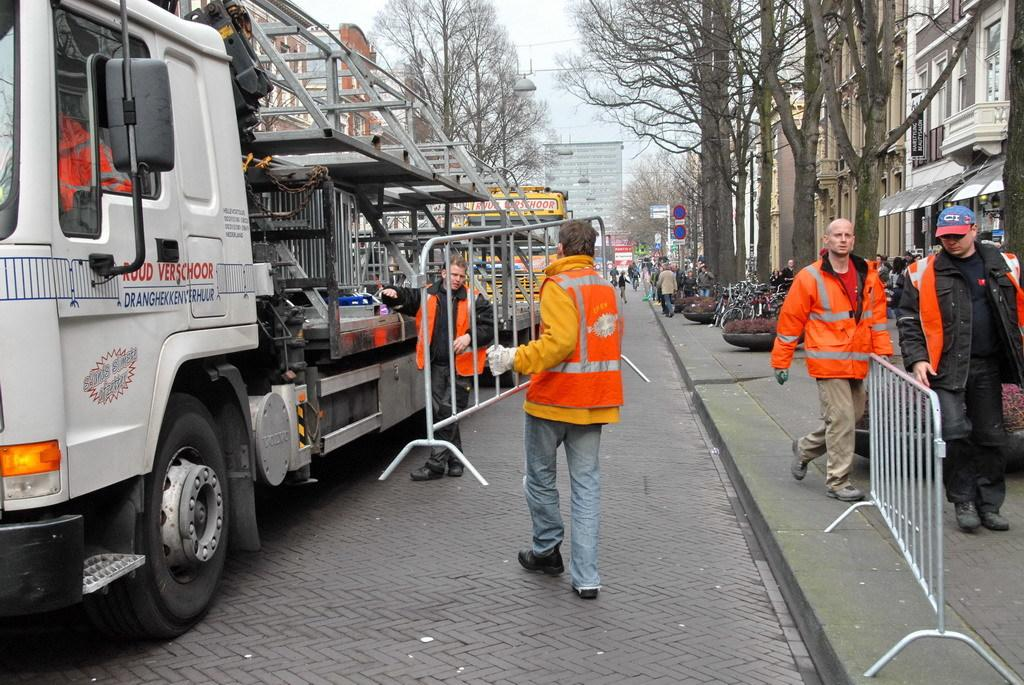What types of objects can be seen in the image? There are vehicles, people, buildings, and trees in the image. Can you describe the setting of the image? The image features vehicles, people, buildings, and trees, which suggests an urban or suburban environment. What else can be seen in the image besides the mentioned objects? There are some unspecified objects in the image. What type of bed can be seen in the image? There is no bed present in the image. What property is being offered for sale in the image? There is no property or offer mentioned in the image. 